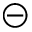<formula> <loc_0><loc_0><loc_500><loc_500>\circleddash</formula> 